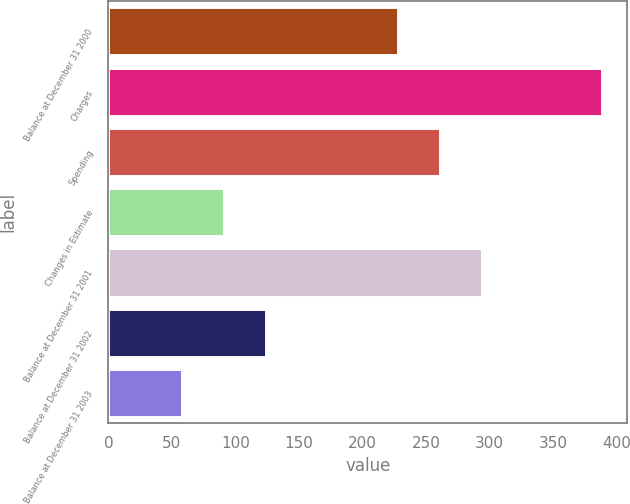<chart> <loc_0><loc_0><loc_500><loc_500><bar_chart><fcel>Balance at December 31 2000<fcel>Charges<fcel>Spending<fcel>Changes in Estimate<fcel>Balance at December 31 2001<fcel>Balance at December 31 2002<fcel>Balance at December 31 2003<nl><fcel>228<fcel>389<fcel>261.1<fcel>91.1<fcel>294.2<fcel>124.2<fcel>58<nl></chart> 